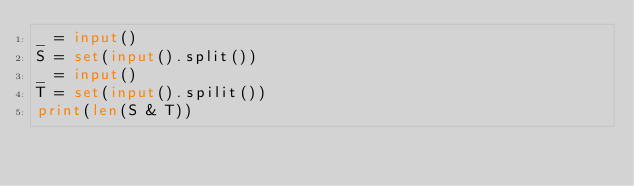<code> <loc_0><loc_0><loc_500><loc_500><_Python_>_ = input()
S = set(input().split())
_ = input()
T = set(input().spilit())
print(len(S & T))</code> 